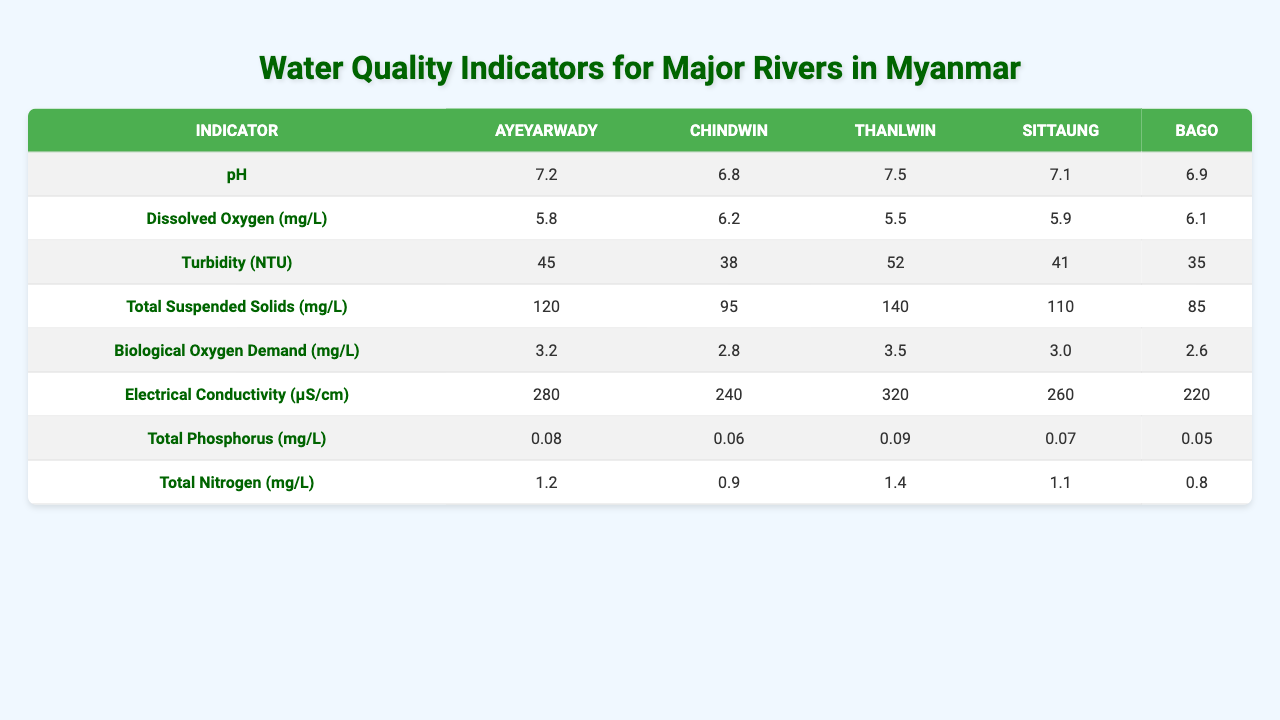What is the pH level of the Ayeyarwady River? Looking at the row for pH levels, the value corresponding to the Ayeyarwady River is 7.2.
Answer: 7.2 What is the average Dissolved Oxygen level across all the rivers listed? To find the average, add the Dissolved Oxygen levels (6.8 + 6.2 + 6.2 + 5.9 + 6.1 = 31.2) and divide by 5 (the number of rivers), which equals 31.2 / 5 = 6.24.
Answer: 6.24 Is the Total Suspended Solids level in the Thanlwin River above 100 mg/L? The Total Suspended Solids level for the Thanlwin River is 110 mg/L, which is above 100 mg/L.
Answer: Yes Which river has the highest Electrical Conductivity value? By comparing the Electrical Conductivity values, Ayeyarwady (280 µS/cm), Chindwin (240 µS/cm), Thanlwin (320 µS/cm), Sittaung (260 µS/cm), and Bago (220 µS/cm), the highest value is 320 µS/cm from the Thanlwin River.
Answer: Thanlwin What is the difference in Total Nitrogen levels between the Ayeyarwady and Sittaung Rivers? The Total Nitrogen level for the Ayeyarwady River is 1.2 mg/L and for the Sittaung River is 1.1 mg/L. The difference is 1.2 - 1.1 = 0.1 mg/L.
Answer: 0.1 mg/L Which river has the lowest Total Phosphorus level and what is that level? By checking the Total Phosphorus levels (Ayeyarwady: 0.08, Chindwin: 0.06, Thanlwin: 0.09, Sittaung: 0.07, Bago: 0.05), Bago has the lowest level at 0.05 mg/L.
Answer: Bago, 0.05 mg/L If we were to categorize the rivers based on Biological Oxygen Demand levels, how many rivers have a BOD level above 3.0 mg/L? The BOD levels are Ayeyarwady (3.2), Chindwin (2.8), Thanlwin (3.5), Sittaung (3.0), and Bago (2.6). Only Ayeyarwady and Thanlwin have BOD levels above 3.0 mg/L, totaling 2 rivers.
Answer: 2 rivers What is the median value of Turbidity across the rivers? The Turbidity values for the rivers (Ayeyarwady: 45, Chindwin: 38, Thanlwin: 52, Sittaung: 41, Bago: 35) when arranged in order (35, 38, 41, 45, 52) give a median of 41 NTU, as it is the middle value.
Answer: 41 NTU Are there any rivers with a pH level below 6.5? The pH levels are 7.2, 6.8, 7.5, 7.1, and 6.9. None of them are below 6.5.
Answer: No What is the sum of Total Suspended Solids for the Ayeyarwady and Chindwin Rivers? The Total Suspended Solids for Ayeyarwady is 120 mg/L and for Chindwin is 95 mg/L. Adding these values gives 120 + 95 = 215 mg/L.
Answer: 215 mg/L 